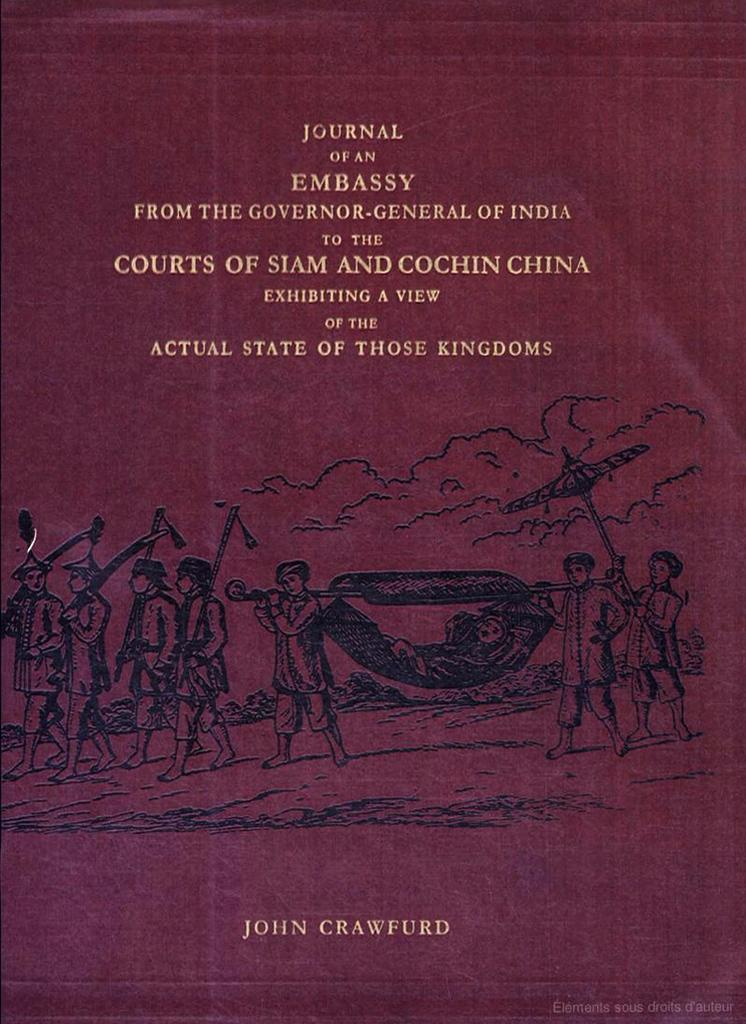<image>
Describe the image concisely. The book Journal of an Embassy from the Governor General of India to the Courts of Siam and Cochin China by John Crawfurd. 